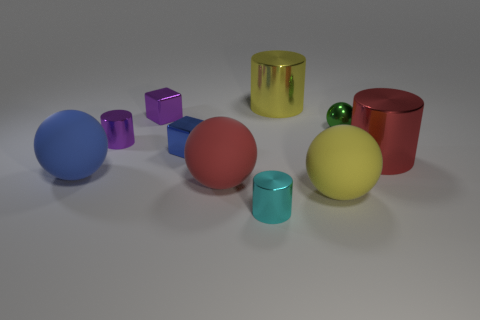Subtract all large matte balls. How many balls are left? 1 Subtract 1 cylinders. How many cylinders are left? 3 Subtract all gray spheres. Subtract all red cubes. How many spheres are left? 4 Subtract all blocks. How many objects are left? 8 Add 4 rubber objects. How many rubber objects exist? 7 Subtract 0 blue cylinders. How many objects are left? 10 Subtract all small cylinders. Subtract all purple cylinders. How many objects are left? 7 Add 5 shiny cylinders. How many shiny cylinders are left? 9 